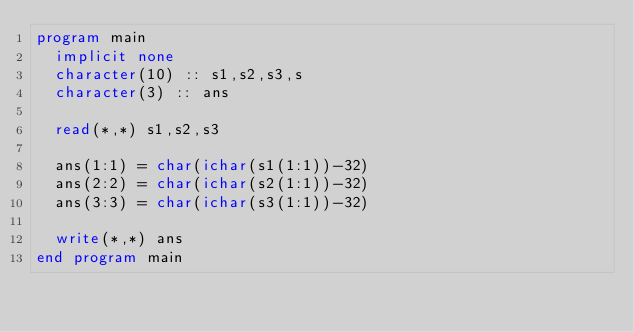Convert code to text. <code><loc_0><loc_0><loc_500><loc_500><_FORTRAN_>program main
  implicit none
  character(10) :: s1,s2,s3,s
  character(3) :: ans

  read(*,*) s1,s2,s3

  ans(1:1) = char(ichar(s1(1:1))-32)
  ans(2:2) = char(ichar(s2(1:1))-32)
  ans(3:3) = char(ichar(s3(1:1))-32)

  write(*,*) ans
end program main
</code> 